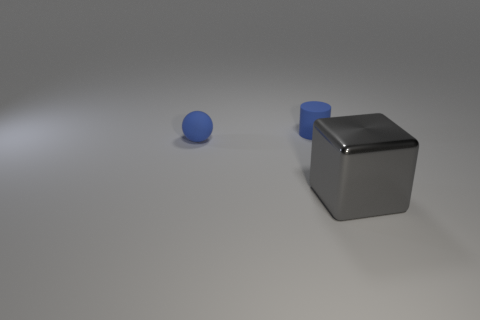Add 3 blue things. How many objects exist? 6 Subtract 1 cylinders. How many cylinders are left? 0 Subtract all cubes. How many objects are left? 2 Subtract all purple balls. Subtract all gray blocks. How many balls are left? 1 Subtract all gray metallic objects. Subtract all tiny matte cylinders. How many objects are left? 1 Add 2 big cubes. How many big cubes are left? 3 Add 3 small yellow balls. How many small yellow balls exist? 3 Subtract 0 green spheres. How many objects are left? 3 